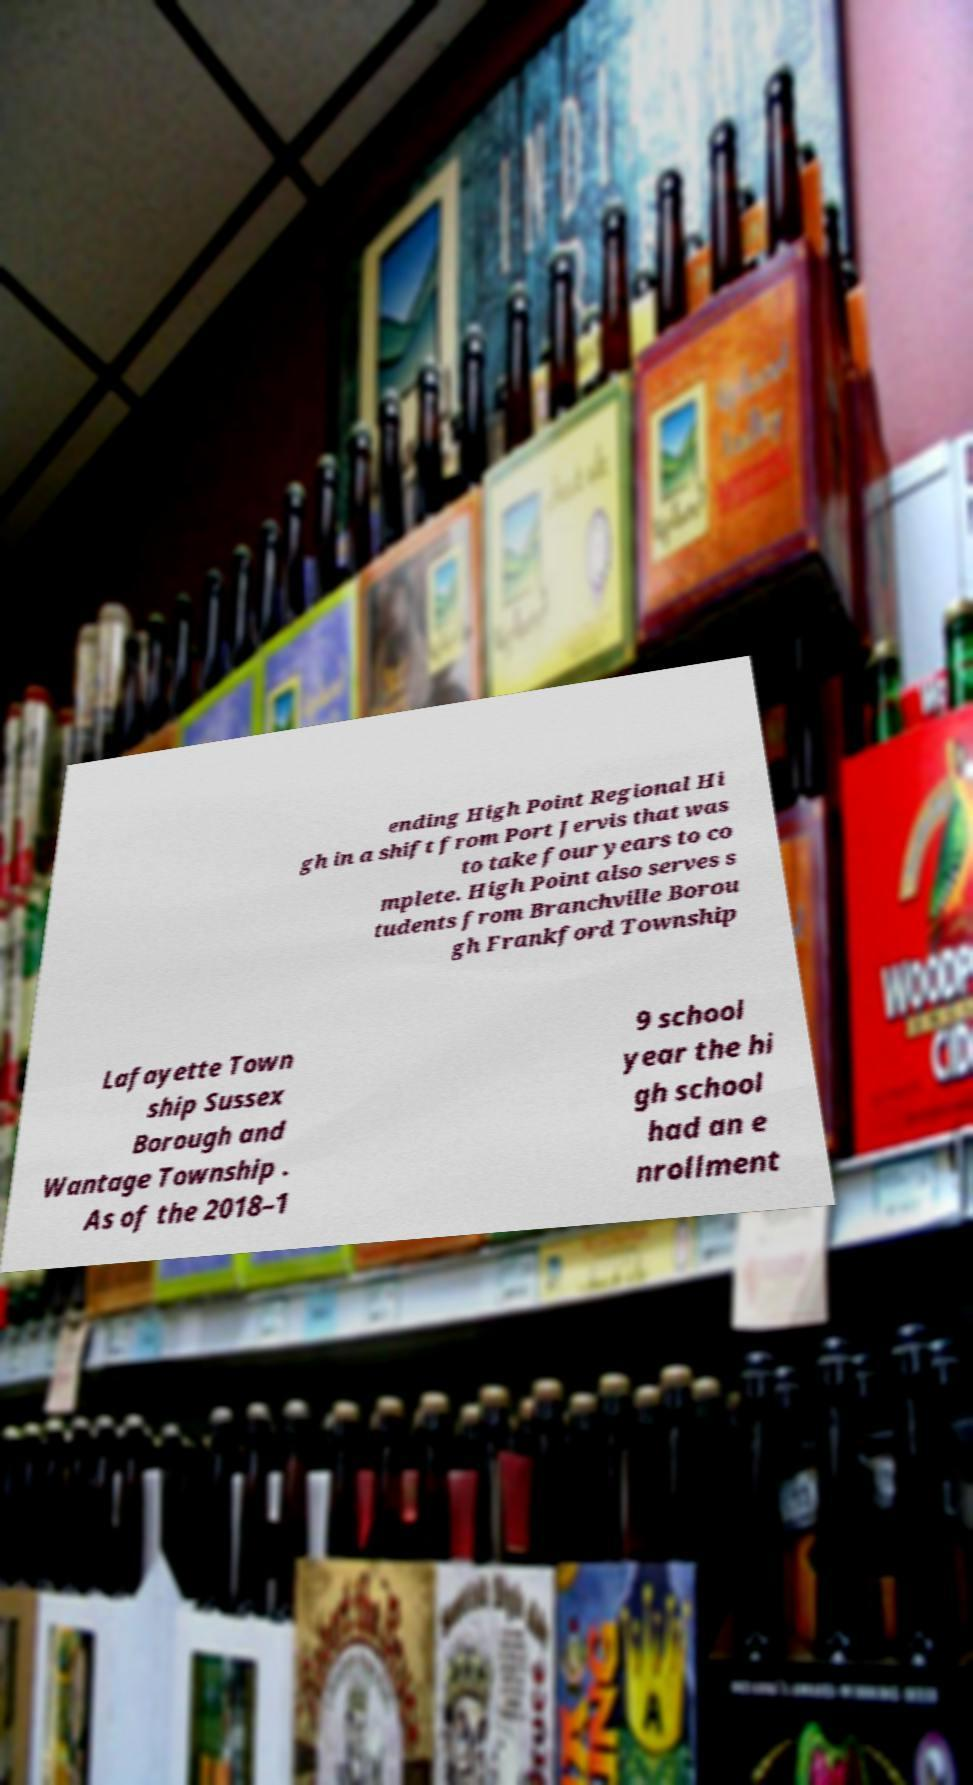For documentation purposes, I need the text within this image transcribed. Could you provide that? ending High Point Regional Hi gh in a shift from Port Jervis that was to take four years to co mplete. High Point also serves s tudents from Branchville Borou gh Frankford Township Lafayette Town ship Sussex Borough and Wantage Township . As of the 2018–1 9 school year the hi gh school had an e nrollment 